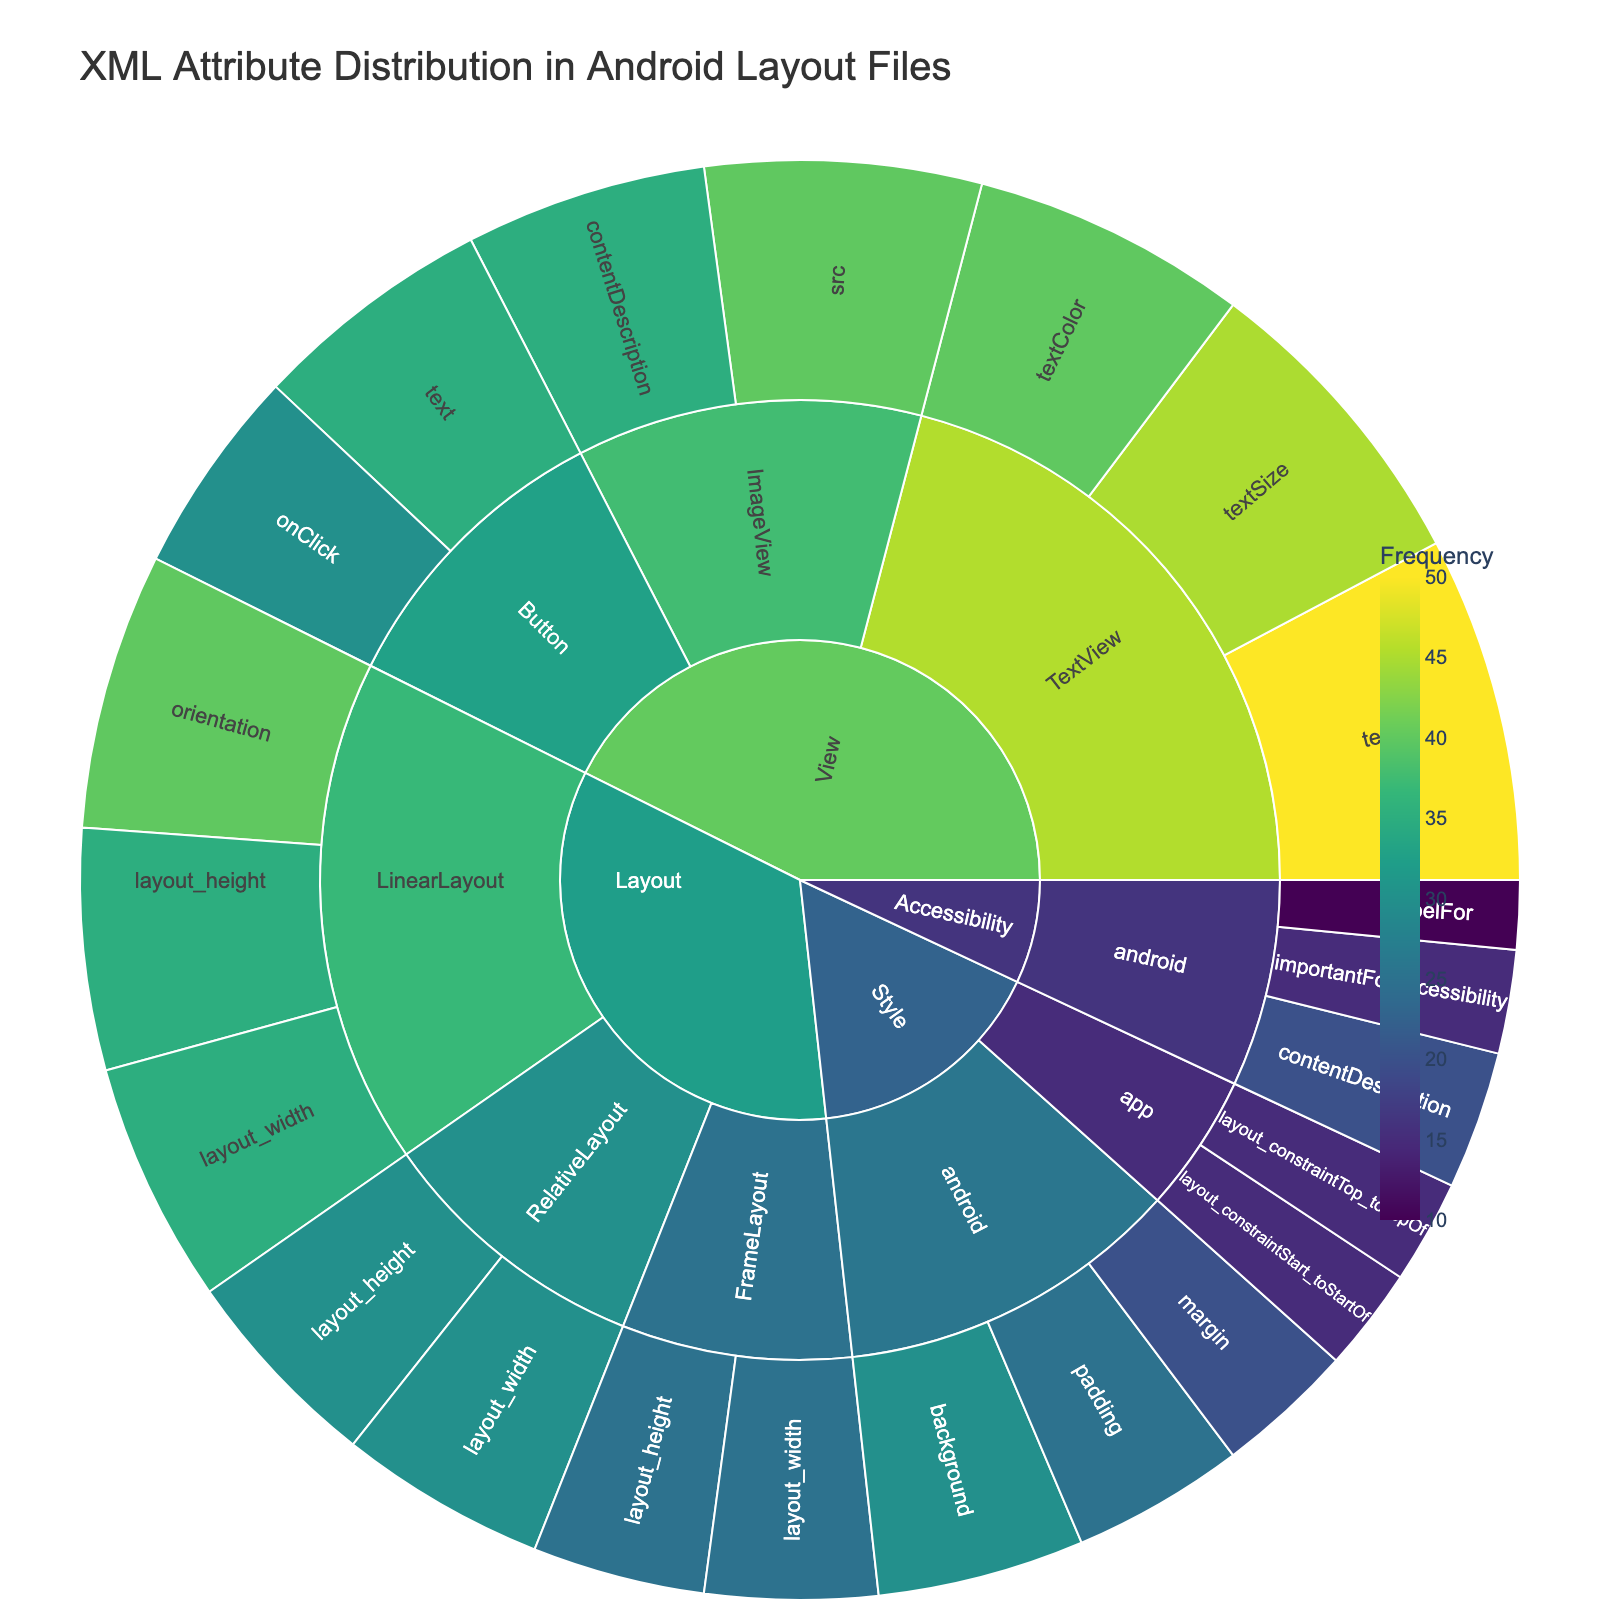What's the most frequently used attribute in TextView? To find this, we look under the "View" category, then "TextView" subcategory, and check which attribute has the highest value. Text has a value of 50, which is the highest.
Answer: text Which category has the highest overall frequency? Summing up the values for each category, we find: Layout (195), View (275), Style (110), and Accessibility (45). View has the highest total.
Answer: View What is the total frequency of all attributes in the "Style" category? We add up the values from the "Style" subcategory: background (30), padding (25), margin (20), layout_constraintTop_toTopOf (15), layout_constraintStart_toStartOf (15). This totals to 105.
Answer: 105 Compare the frequencies of 'text' attribute in TextView and Button. Which is more frequent and by how much? The TextView 'text' attribute has a value of 50, while the Button 'text' attribute has 35. The difference is 50 - 35 = 15.
Answer: TextView is more frequent by 15 What is the combined frequency of 'layout_width' attributes across all layouts? Add the 'layout_width' values: LinearLayout (35), RelativeLayout (30), and FrameLayout (25). This totals to 90.
Answer: 90 Which subcategory under "Accessibility" has the least frequency and what's its value? Under "Accessibility", we compare contentDescription (20), importantForAccessibility (15), and labelFor (10). LabelFor has the least with a value of 10.
Answer: labelFor, 10 How many subcategories are within the "View" category? Under the View category, the subcategories are TextView, Button, and ImageView. Thus, there are 3 subcategories.
Answer: 3 Is 'orientation' more frequent in LinearLayout or any attribute in FrameLayout? If so, by how much? The 'orientation' in LinearLayout is 40. Comparing this to the attributes in FrameLayout: 'layout_width' (25) and 'layout_height' (25). The orientation in LinearLayout is indeed more frequent by 40 - 25 = 15.
Answer: Yes, by 15 Overall, how does the usage of attributes in "Accessibility" compare to "Style"? Total the values in Accessibility (contentDescription 20, importantForAccessibility 15, labelFor 10) for 45. For Style (background 30, padding 25, margin 20, layout_constraintTop_toTopOf 15, layout_constraintStart_toStartOf 15), we have 105. Style is 60 more frequent than Accessibility.
Answer: Style is 60 more frequent Which attribute under "android" appears both in "Style" and "Accessibility" and what is its combined frequency? In both categories under "android", contentDescription appears in both (20 in Accessibility and 30 in Style), totaling 20 + 20 = 40.
Answer: contentDescription, 40 